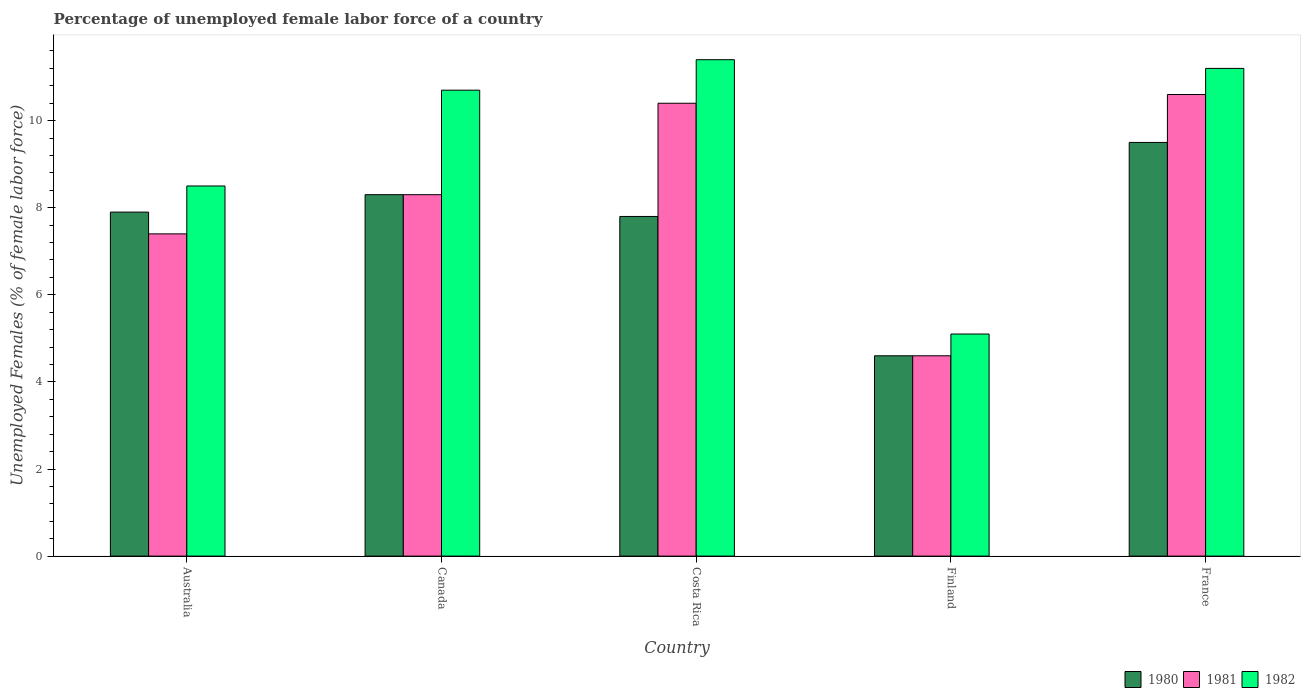How many different coloured bars are there?
Provide a succinct answer. 3. How many groups of bars are there?
Your response must be concise. 5. How many bars are there on the 2nd tick from the right?
Provide a succinct answer. 3. In how many cases, is the number of bars for a given country not equal to the number of legend labels?
Your answer should be very brief. 0. What is the percentage of unemployed female labor force in 1980 in France?
Provide a succinct answer. 9.5. Across all countries, what is the maximum percentage of unemployed female labor force in 1982?
Your response must be concise. 11.4. Across all countries, what is the minimum percentage of unemployed female labor force in 1982?
Your answer should be compact. 5.1. In which country was the percentage of unemployed female labor force in 1981 maximum?
Your answer should be compact. France. What is the total percentage of unemployed female labor force in 1980 in the graph?
Keep it short and to the point. 38.1. What is the difference between the percentage of unemployed female labor force in 1981 in Canada and that in France?
Ensure brevity in your answer.  -2.3. What is the difference between the percentage of unemployed female labor force in 1982 in Costa Rica and the percentage of unemployed female labor force in 1980 in Australia?
Offer a terse response. 3.5. What is the average percentage of unemployed female labor force in 1981 per country?
Your answer should be very brief. 8.26. What is the difference between the percentage of unemployed female labor force of/in 1980 and percentage of unemployed female labor force of/in 1981 in Costa Rica?
Ensure brevity in your answer.  -2.6. In how many countries, is the percentage of unemployed female labor force in 1981 greater than 8.4 %?
Provide a succinct answer. 2. What is the ratio of the percentage of unemployed female labor force in 1981 in Finland to that in France?
Provide a succinct answer. 0.43. Is the difference between the percentage of unemployed female labor force in 1980 in Australia and Finland greater than the difference between the percentage of unemployed female labor force in 1981 in Australia and Finland?
Your response must be concise. Yes. What is the difference between the highest and the second highest percentage of unemployed female labor force in 1980?
Offer a very short reply. -1.2. What is the difference between the highest and the lowest percentage of unemployed female labor force in 1980?
Keep it short and to the point. 4.9. In how many countries, is the percentage of unemployed female labor force in 1981 greater than the average percentage of unemployed female labor force in 1981 taken over all countries?
Make the answer very short. 3. What does the 2nd bar from the left in Finland represents?
Provide a succinct answer. 1981. Is it the case that in every country, the sum of the percentage of unemployed female labor force in 1982 and percentage of unemployed female labor force in 1981 is greater than the percentage of unemployed female labor force in 1980?
Your answer should be very brief. Yes. Are all the bars in the graph horizontal?
Keep it short and to the point. No. Where does the legend appear in the graph?
Your response must be concise. Bottom right. How are the legend labels stacked?
Your answer should be very brief. Horizontal. What is the title of the graph?
Give a very brief answer. Percentage of unemployed female labor force of a country. Does "1999" appear as one of the legend labels in the graph?
Give a very brief answer. No. What is the label or title of the Y-axis?
Offer a terse response. Unemployed Females (% of female labor force). What is the Unemployed Females (% of female labor force) in 1980 in Australia?
Ensure brevity in your answer.  7.9. What is the Unemployed Females (% of female labor force) of 1981 in Australia?
Give a very brief answer. 7.4. What is the Unemployed Females (% of female labor force) in 1980 in Canada?
Keep it short and to the point. 8.3. What is the Unemployed Females (% of female labor force) of 1981 in Canada?
Keep it short and to the point. 8.3. What is the Unemployed Females (% of female labor force) of 1982 in Canada?
Make the answer very short. 10.7. What is the Unemployed Females (% of female labor force) of 1980 in Costa Rica?
Offer a terse response. 7.8. What is the Unemployed Females (% of female labor force) in 1981 in Costa Rica?
Make the answer very short. 10.4. What is the Unemployed Females (% of female labor force) of 1982 in Costa Rica?
Provide a short and direct response. 11.4. What is the Unemployed Females (% of female labor force) of 1980 in Finland?
Give a very brief answer. 4.6. What is the Unemployed Females (% of female labor force) in 1981 in Finland?
Offer a terse response. 4.6. What is the Unemployed Females (% of female labor force) in 1982 in Finland?
Offer a very short reply. 5.1. What is the Unemployed Females (% of female labor force) of 1980 in France?
Make the answer very short. 9.5. What is the Unemployed Females (% of female labor force) in 1981 in France?
Provide a succinct answer. 10.6. What is the Unemployed Females (% of female labor force) in 1982 in France?
Offer a terse response. 11.2. Across all countries, what is the maximum Unemployed Females (% of female labor force) in 1981?
Make the answer very short. 10.6. Across all countries, what is the maximum Unemployed Females (% of female labor force) of 1982?
Your answer should be very brief. 11.4. Across all countries, what is the minimum Unemployed Females (% of female labor force) of 1980?
Offer a very short reply. 4.6. Across all countries, what is the minimum Unemployed Females (% of female labor force) of 1981?
Ensure brevity in your answer.  4.6. Across all countries, what is the minimum Unemployed Females (% of female labor force) of 1982?
Make the answer very short. 5.1. What is the total Unemployed Females (% of female labor force) in 1980 in the graph?
Your answer should be very brief. 38.1. What is the total Unemployed Females (% of female labor force) of 1981 in the graph?
Offer a terse response. 41.3. What is the total Unemployed Females (% of female labor force) in 1982 in the graph?
Your response must be concise. 46.9. What is the difference between the Unemployed Females (% of female labor force) in 1981 in Australia and that in Canada?
Keep it short and to the point. -0.9. What is the difference between the Unemployed Females (% of female labor force) of 1981 in Australia and that in Finland?
Offer a terse response. 2.8. What is the difference between the Unemployed Females (% of female labor force) in 1982 in Australia and that in France?
Your answer should be very brief. -2.7. What is the difference between the Unemployed Females (% of female labor force) of 1980 in Canada and that in Costa Rica?
Provide a succinct answer. 0.5. What is the difference between the Unemployed Females (% of female labor force) of 1981 in Canada and that in Costa Rica?
Offer a very short reply. -2.1. What is the difference between the Unemployed Females (% of female labor force) of 1981 in Canada and that in Finland?
Your answer should be very brief. 3.7. What is the difference between the Unemployed Females (% of female labor force) in 1982 in Canada and that in Finland?
Offer a very short reply. 5.6. What is the difference between the Unemployed Females (% of female labor force) of 1980 in Canada and that in France?
Offer a terse response. -1.2. What is the difference between the Unemployed Females (% of female labor force) of 1982 in Costa Rica and that in Finland?
Give a very brief answer. 6.3. What is the difference between the Unemployed Females (% of female labor force) of 1980 in Finland and that in France?
Your response must be concise. -4.9. What is the difference between the Unemployed Females (% of female labor force) of 1980 in Australia and the Unemployed Females (% of female labor force) of 1981 in Canada?
Offer a terse response. -0.4. What is the difference between the Unemployed Females (% of female labor force) of 1980 in Australia and the Unemployed Females (% of female labor force) of 1981 in Costa Rica?
Your answer should be compact. -2.5. What is the difference between the Unemployed Females (% of female labor force) in 1980 in Australia and the Unemployed Females (% of female labor force) in 1982 in Costa Rica?
Your response must be concise. -3.5. What is the difference between the Unemployed Females (% of female labor force) in 1980 in Australia and the Unemployed Females (% of female labor force) in 1982 in Finland?
Your answer should be compact. 2.8. What is the difference between the Unemployed Females (% of female labor force) in 1980 in Australia and the Unemployed Females (% of female labor force) in 1981 in France?
Your answer should be very brief. -2.7. What is the difference between the Unemployed Females (% of female labor force) in 1980 in Australia and the Unemployed Females (% of female labor force) in 1982 in France?
Provide a short and direct response. -3.3. What is the difference between the Unemployed Females (% of female labor force) of 1980 in Canada and the Unemployed Females (% of female labor force) of 1981 in Costa Rica?
Your answer should be compact. -2.1. What is the difference between the Unemployed Females (% of female labor force) of 1980 in Canada and the Unemployed Females (% of female labor force) of 1982 in Costa Rica?
Keep it short and to the point. -3.1. What is the difference between the Unemployed Females (% of female labor force) of 1980 in Canada and the Unemployed Females (% of female labor force) of 1982 in Finland?
Your response must be concise. 3.2. What is the difference between the Unemployed Females (% of female labor force) of 1981 in Canada and the Unemployed Females (% of female labor force) of 1982 in Finland?
Your answer should be compact. 3.2. What is the difference between the Unemployed Females (% of female labor force) in 1980 in Canada and the Unemployed Females (% of female labor force) in 1982 in France?
Provide a short and direct response. -2.9. What is the difference between the Unemployed Females (% of female labor force) of 1981 in Canada and the Unemployed Females (% of female labor force) of 1982 in France?
Provide a succinct answer. -2.9. What is the difference between the Unemployed Females (% of female labor force) of 1980 in Costa Rica and the Unemployed Females (% of female labor force) of 1981 in Finland?
Your response must be concise. 3.2. What is the difference between the Unemployed Females (% of female labor force) in 1980 in Costa Rica and the Unemployed Females (% of female labor force) in 1982 in Finland?
Offer a very short reply. 2.7. What is the difference between the Unemployed Females (% of female labor force) in 1981 in Costa Rica and the Unemployed Females (% of female labor force) in 1982 in Finland?
Make the answer very short. 5.3. What is the difference between the Unemployed Females (% of female labor force) of 1980 in Costa Rica and the Unemployed Females (% of female labor force) of 1981 in France?
Your response must be concise. -2.8. What is the difference between the Unemployed Females (% of female labor force) of 1980 in Costa Rica and the Unemployed Females (% of female labor force) of 1982 in France?
Ensure brevity in your answer.  -3.4. What is the difference between the Unemployed Females (% of female labor force) in 1981 in Finland and the Unemployed Females (% of female labor force) in 1982 in France?
Provide a succinct answer. -6.6. What is the average Unemployed Females (% of female labor force) of 1980 per country?
Your answer should be very brief. 7.62. What is the average Unemployed Females (% of female labor force) of 1981 per country?
Ensure brevity in your answer.  8.26. What is the average Unemployed Females (% of female labor force) in 1982 per country?
Give a very brief answer. 9.38. What is the difference between the Unemployed Females (% of female labor force) of 1980 and Unemployed Females (% of female labor force) of 1981 in Australia?
Your answer should be very brief. 0.5. What is the difference between the Unemployed Females (% of female labor force) in 1980 and Unemployed Females (% of female labor force) in 1982 in Australia?
Ensure brevity in your answer.  -0.6. What is the difference between the Unemployed Females (% of female labor force) of 1981 and Unemployed Females (% of female labor force) of 1982 in Australia?
Ensure brevity in your answer.  -1.1. What is the difference between the Unemployed Females (% of female labor force) of 1980 and Unemployed Females (% of female labor force) of 1982 in Canada?
Give a very brief answer. -2.4. What is the difference between the Unemployed Females (% of female labor force) in 1981 and Unemployed Females (% of female labor force) in 1982 in Canada?
Make the answer very short. -2.4. What is the difference between the Unemployed Females (% of female labor force) of 1981 and Unemployed Females (% of female labor force) of 1982 in Costa Rica?
Your answer should be compact. -1. What is the difference between the Unemployed Females (% of female labor force) of 1980 and Unemployed Females (% of female labor force) of 1981 in Finland?
Your answer should be very brief. 0. What is the difference between the Unemployed Females (% of female labor force) in 1980 and Unemployed Females (% of female labor force) in 1982 in Finland?
Make the answer very short. -0.5. What is the difference between the Unemployed Females (% of female labor force) in 1981 and Unemployed Females (% of female labor force) in 1982 in Finland?
Your answer should be very brief. -0.5. What is the difference between the Unemployed Females (% of female labor force) of 1980 and Unemployed Females (% of female labor force) of 1982 in France?
Offer a very short reply. -1.7. What is the difference between the Unemployed Females (% of female labor force) of 1981 and Unemployed Females (% of female labor force) of 1982 in France?
Your answer should be compact. -0.6. What is the ratio of the Unemployed Females (% of female labor force) of 1980 in Australia to that in Canada?
Provide a succinct answer. 0.95. What is the ratio of the Unemployed Females (% of female labor force) of 1981 in Australia to that in Canada?
Keep it short and to the point. 0.89. What is the ratio of the Unemployed Females (% of female labor force) of 1982 in Australia to that in Canada?
Ensure brevity in your answer.  0.79. What is the ratio of the Unemployed Females (% of female labor force) in 1980 in Australia to that in Costa Rica?
Your answer should be compact. 1.01. What is the ratio of the Unemployed Females (% of female labor force) of 1981 in Australia to that in Costa Rica?
Your answer should be very brief. 0.71. What is the ratio of the Unemployed Females (% of female labor force) of 1982 in Australia to that in Costa Rica?
Offer a very short reply. 0.75. What is the ratio of the Unemployed Females (% of female labor force) of 1980 in Australia to that in Finland?
Offer a terse response. 1.72. What is the ratio of the Unemployed Females (% of female labor force) of 1981 in Australia to that in Finland?
Offer a very short reply. 1.61. What is the ratio of the Unemployed Females (% of female labor force) of 1982 in Australia to that in Finland?
Make the answer very short. 1.67. What is the ratio of the Unemployed Females (% of female labor force) of 1980 in Australia to that in France?
Provide a succinct answer. 0.83. What is the ratio of the Unemployed Females (% of female labor force) in 1981 in Australia to that in France?
Offer a very short reply. 0.7. What is the ratio of the Unemployed Females (% of female labor force) of 1982 in Australia to that in France?
Your answer should be very brief. 0.76. What is the ratio of the Unemployed Females (% of female labor force) of 1980 in Canada to that in Costa Rica?
Make the answer very short. 1.06. What is the ratio of the Unemployed Females (% of female labor force) in 1981 in Canada to that in Costa Rica?
Provide a short and direct response. 0.8. What is the ratio of the Unemployed Females (% of female labor force) of 1982 in Canada to that in Costa Rica?
Offer a terse response. 0.94. What is the ratio of the Unemployed Females (% of female labor force) of 1980 in Canada to that in Finland?
Give a very brief answer. 1.8. What is the ratio of the Unemployed Females (% of female labor force) in 1981 in Canada to that in Finland?
Provide a short and direct response. 1.8. What is the ratio of the Unemployed Females (% of female labor force) in 1982 in Canada to that in Finland?
Your response must be concise. 2.1. What is the ratio of the Unemployed Females (% of female labor force) in 1980 in Canada to that in France?
Your response must be concise. 0.87. What is the ratio of the Unemployed Females (% of female labor force) of 1981 in Canada to that in France?
Provide a short and direct response. 0.78. What is the ratio of the Unemployed Females (% of female labor force) in 1982 in Canada to that in France?
Ensure brevity in your answer.  0.96. What is the ratio of the Unemployed Females (% of female labor force) in 1980 in Costa Rica to that in Finland?
Give a very brief answer. 1.7. What is the ratio of the Unemployed Females (% of female labor force) in 1981 in Costa Rica to that in Finland?
Keep it short and to the point. 2.26. What is the ratio of the Unemployed Females (% of female labor force) in 1982 in Costa Rica to that in Finland?
Keep it short and to the point. 2.24. What is the ratio of the Unemployed Females (% of female labor force) in 1980 in Costa Rica to that in France?
Offer a terse response. 0.82. What is the ratio of the Unemployed Females (% of female labor force) of 1981 in Costa Rica to that in France?
Keep it short and to the point. 0.98. What is the ratio of the Unemployed Females (% of female labor force) of 1982 in Costa Rica to that in France?
Your response must be concise. 1.02. What is the ratio of the Unemployed Females (% of female labor force) in 1980 in Finland to that in France?
Your answer should be very brief. 0.48. What is the ratio of the Unemployed Females (% of female labor force) of 1981 in Finland to that in France?
Keep it short and to the point. 0.43. What is the ratio of the Unemployed Females (% of female labor force) in 1982 in Finland to that in France?
Your response must be concise. 0.46. What is the difference between the highest and the second highest Unemployed Females (% of female labor force) in 1980?
Give a very brief answer. 1.2. What is the difference between the highest and the second highest Unemployed Females (% of female labor force) of 1981?
Ensure brevity in your answer.  0.2. What is the difference between the highest and the second highest Unemployed Females (% of female labor force) in 1982?
Offer a very short reply. 0.2. What is the difference between the highest and the lowest Unemployed Females (% of female labor force) in 1981?
Provide a short and direct response. 6. 